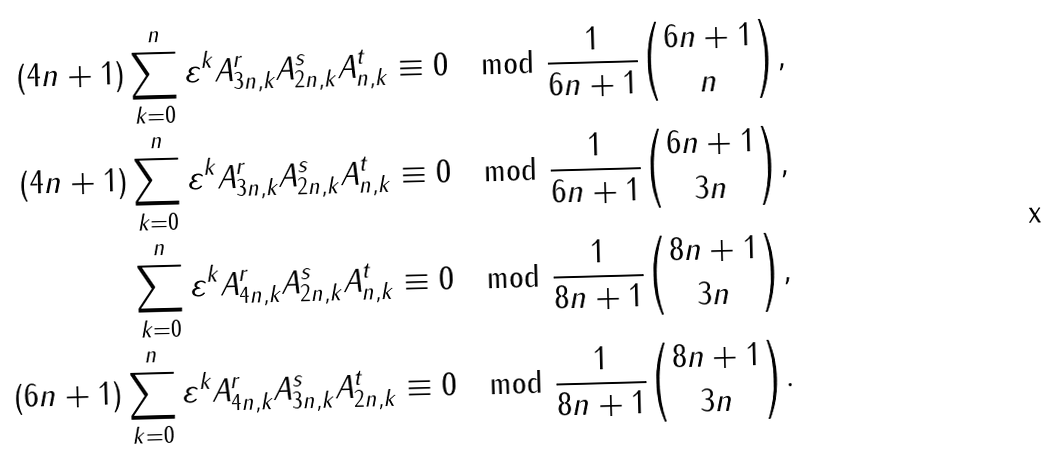Convert formula to latex. <formula><loc_0><loc_0><loc_500><loc_500>( 4 n + 1 ) \sum _ { k = 0 } ^ { n } \varepsilon ^ { k } A _ { 3 n , k } ^ { r } A _ { 2 n , k } ^ { s } A _ { n , k } ^ { t } & \equiv 0 \mod \frac { 1 } { 6 n + 1 } { 6 n + 1 \choose n } , \\ ( 4 n + 1 ) \sum _ { k = 0 } ^ { n } \varepsilon ^ { k } A _ { 3 n , k } ^ { r } A _ { 2 n , k } ^ { s } A _ { n , k } ^ { t } & \equiv 0 \mod \frac { 1 } { 6 n + 1 } { 6 n + 1 \choose 3 n } , \\ \sum _ { k = 0 } ^ { n } \varepsilon ^ { k } A _ { 4 n , k } ^ { r } A _ { 2 n , k } ^ { s } A _ { n , k } ^ { t } & \equiv 0 \mod \frac { 1 } { 8 n + 1 } { 8 n + 1 \choose 3 n } , \\ ( 6 n + 1 ) \sum _ { k = 0 } ^ { n } \varepsilon ^ { k } A _ { 4 n , k } ^ { r } A _ { 3 n , k } ^ { s } A _ { 2 n , k } ^ { t } & \equiv 0 \mod \frac { 1 } { 8 n + 1 } { 8 n + 1 \choose 3 n } .</formula> 